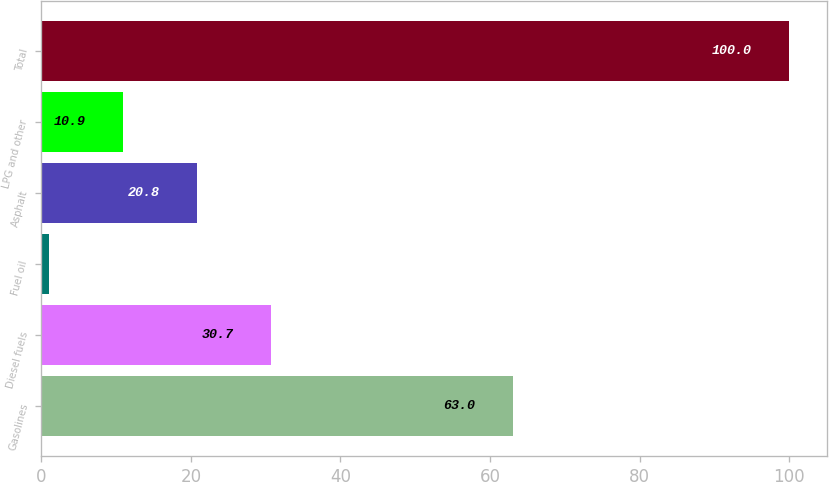<chart> <loc_0><loc_0><loc_500><loc_500><bar_chart><fcel>Gasolines<fcel>Diesel fuels<fcel>Fuel oil<fcel>Asphalt<fcel>LPG and other<fcel>Total<nl><fcel>63<fcel>30.7<fcel>1<fcel>20.8<fcel>10.9<fcel>100<nl></chart> 